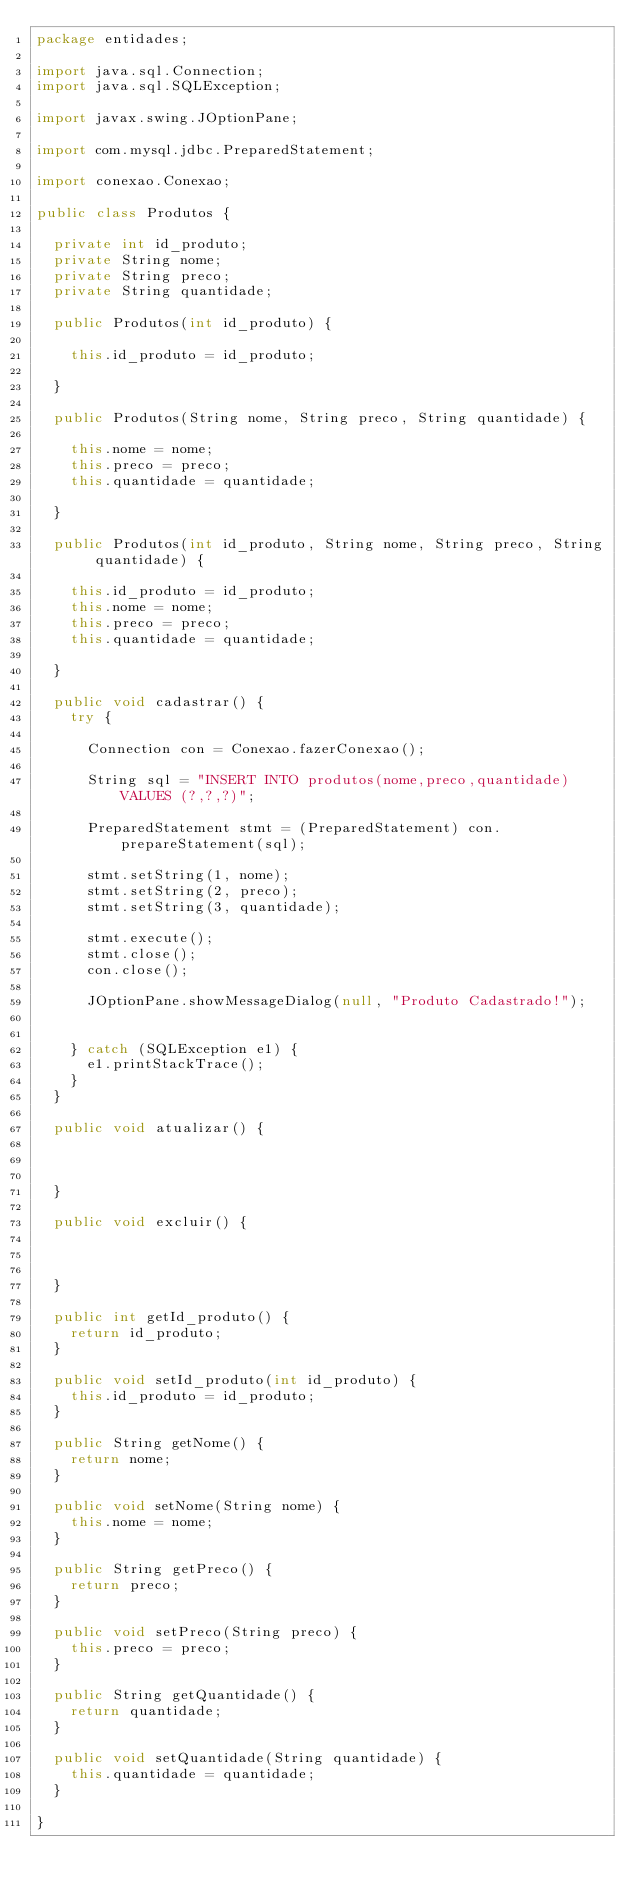<code> <loc_0><loc_0><loc_500><loc_500><_Java_>package entidades;

import java.sql.Connection;
import java.sql.SQLException;

import javax.swing.JOptionPane;

import com.mysql.jdbc.PreparedStatement;

import conexao.Conexao;

public class Produtos {
	
	private int id_produto;
	private String nome;
	private String preco;
	private String quantidade;
	
	public Produtos(int id_produto) {
		
		this.id_produto = id_produto;
		
	}
	
	public Produtos(String nome, String preco, String quantidade) {
		
		this.nome = nome;
		this.preco = preco;
		this.quantidade = quantidade;
		
	}
	
	public Produtos(int id_produto, String nome, String preco, String quantidade) {
		
		this.id_produto = id_produto;
		this.nome = nome;
		this.preco = preco;
		this.quantidade = quantidade;
		
	}
	
	public void cadastrar() {
		try {
			
			Connection con = Conexao.fazerConexao();
			
			String sql = "INSERT INTO produtos(nome,preco,quantidade) VALUES (?,?,?)";
			
			PreparedStatement stmt = (PreparedStatement) con.prepareStatement(sql);
			
			stmt.setString(1, nome);
			stmt.setString(2, preco);
			stmt.setString(3, quantidade);
			
			stmt.execute();
			stmt.close();
			con.close();
			
			JOptionPane.showMessageDialog(null, "Produto Cadastrado!");
			
			
		} catch (SQLException e1) {
			e1.printStackTrace();
		}
	}
	
	public void atualizar() {
		
		
		
	}
	
	public void excluir() {
		
		
		
	}

	public int getId_produto() {
		return id_produto;
	}

	public void setId_produto(int id_produto) {
		this.id_produto = id_produto;
	}

	public String getNome() {
		return nome;
	}

	public void setNome(String nome) {
		this.nome = nome;
	}

	public String getPreco() {
		return preco;
	}

	public void setPreco(String preco) {
		this.preco = preco;
	}

	public String getQuantidade() {
		return quantidade;
	}

	public void setQuantidade(String quantidade) {
		this.quantidade = quantidade;
	}

}
</code> 